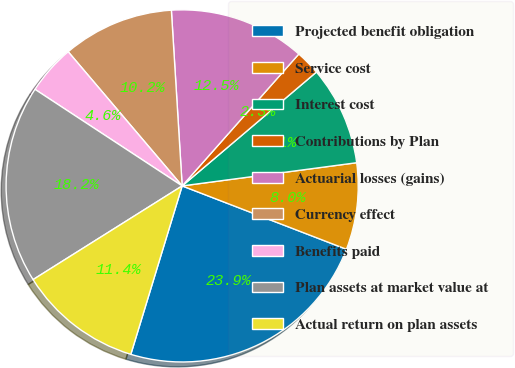Convert chart to OTSL. <chart><loc_0><loc_0><loc_500><loc_500><pie_chart><fcel>Projected benefit obligation<fcel>Service cost<fcel>Interest cost<fcel>Contributions by Plan<fcel>Actuarial losses (gains)<fcel>Currency effect<fcel>Benefits paid<fcel>Plan assets at market value at<fcel>Actual return on plan assets<nl><fcel>23.85%<fcel>7.96%<fcel>9.09%<fcel>2.28%<fcel>12.5%<fcel>10.23%<fcel>4.55%<fcel>18.17%<fcel>11.36%<nl></chart> 